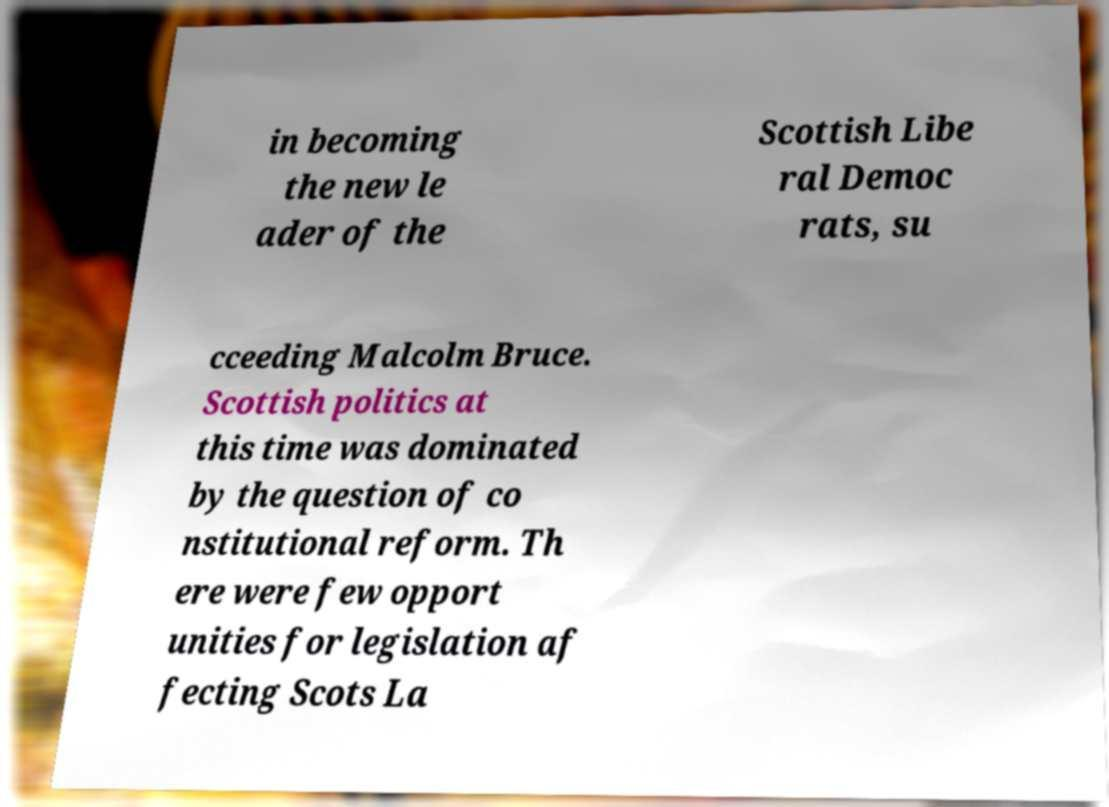Please identify and transcribe the text found in this image. in becoming the new le ader of the Scottish Libe ral Democ rats, su cceeding Malcolm Bruce. Scottish politics at this time was dominated by the question of co nstitutional reform. Th ere were few opport unities for legislation af fecting Scots La 